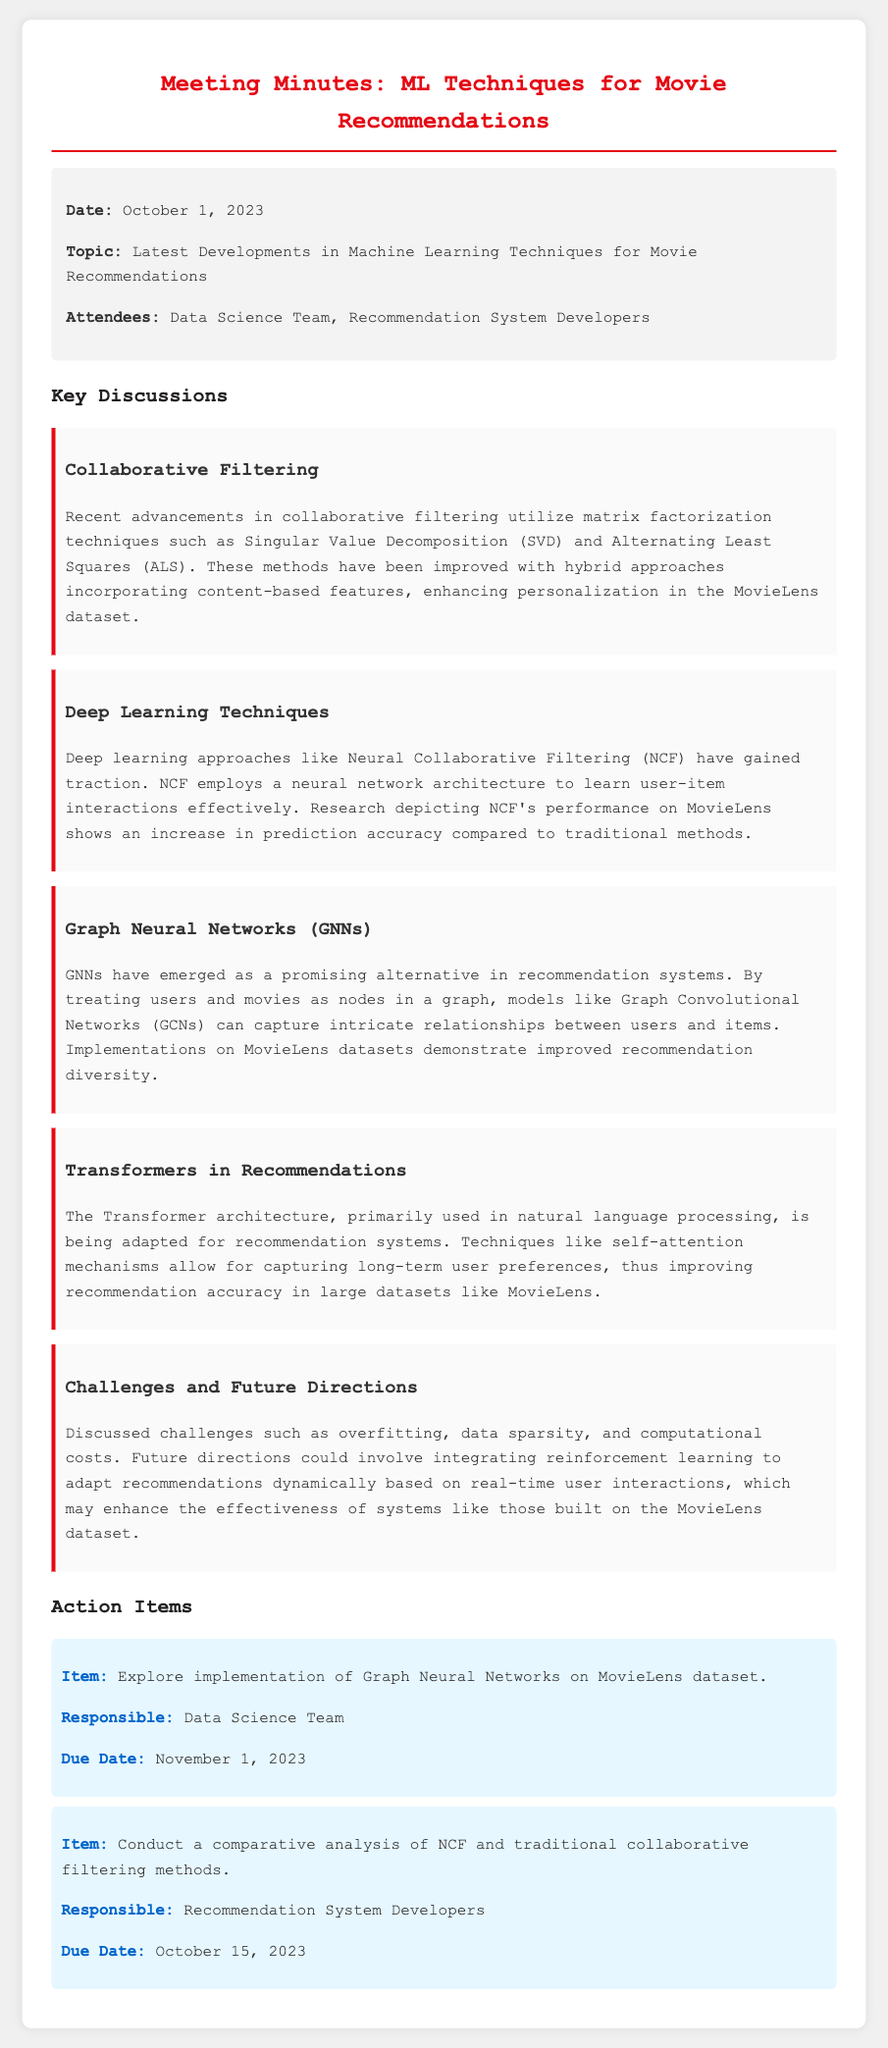What is the date of the meeting? The meeting date is explicitly stated in the document under the info section.
Answer: October 1, 2023 What technique is highlighted for improving collaborative filtering? The document mentions matrix factorization techniques among other improvements for collaborative filtering.
Answer: Singular Value Decomposition What deep learning approach is mentioned in the document? The document specifies a type of deep learning approach used for recommendations under the deep learning techniques section.
Answer: Neural Collaborative Filtering What are GNNs used for according to the meeting minutes? The document describes GNNs as an alternative in recommendation systems specifically in relation to how they model user-item interactions.
Answer: Capturing intricate relationships Which aspect of recommendation systems is being adapted from natural language processing? The document states the adaptation of a specific architecture used in natural language processing for recommendation systems.
Answer: Transformer What is one of the challenges discussed in the meeting? The minutes mention various challenges faced in machine learning techniques for recommendations.
Answer: Overfitting What is the due date for exploring the implementation of Graph Neural Networks? The due date is provided within the action items section in the document regarding this task.
Answer: November 1, 2023 Who is responsible for conducting a comparative analysis of NCF? The document lists the responsible team in the action items section related to this task.
Answer: Recommendation System Developers 